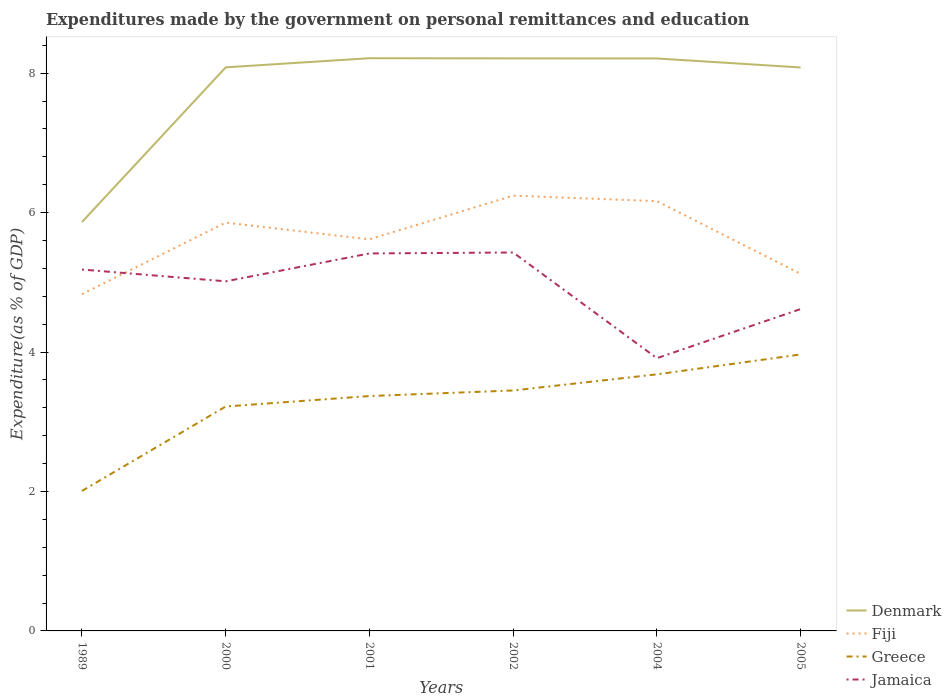Is the number of lines equal to the number of legend labels?
Your answer should be compact. Yes. Across all years, what is the maximum expenditures made by the government on personal remittances and education in Jamaica?
Provide a short and direct response. 3.91. What is the total expenditures made by the government on personal remittances and education in Greece in the graph?
Ensure brevity in your answer.  -0.31. What is the difference between the highest and the second highest expenditures made by the government on personal remittances and education in Greece?
Your answer should be very brief. 1.96. What is the difference between the highest and the lowest expenditures made by the government on personal remittances and education in Denmark?
Provide a short and direct response. 5. How many years are there in the graph?
Provide a short and direct response. 6. What is the difference between two consecutive major ticks on the Y-axis?
Make the answer very short. 2. Does the graph contain any zero values?
Provide a short and direct response. No. Does the graph contain grids?
Offer a terse response. No. How many legend labels are there?
Your answer should be very brief. 4. What is the title of the graph?
Offer a terse response. Expenditures made by the government on personal remittances and education. Does "Zimbabwe" appear as one of the legend labels in the graph?
Your response must be concise. No. What is the label or title of the X-axis?
Make the answer very short. Years. What is the label or title of the Y-axis?
Your response must be concise. Expenditure(as % of GDP). What is the Expenditure(as % of GDP) of Denmark in 1989?
Make the answer very short. 5.87. What is the Expenditure(as % of GDP) of Fiji in 1989?
Provide a succinct answer. 4.83. What is the Expenditure(as % of GDP) of Greece in 1989?
Give a very brief answer. 2.01. What is the Expenditure(as % of GDP) in Jamaica in 1989?
Keep it short and to the point. 5.18. What is the Expenditure(as % of GDP) in Denmark in 2000?
Your answer should be very brief. 8.08. What is the Expenditure(as % of GDP) in Fiji in 2000?
Your response must be concise. 5.86. What is the Expenditure(as % of GDP) in Greece in 2000?
Keep it short and to the point. 3.22. What is the Expenditure(as % of GDP) of Jamaica in 2000?
Make the answer very short. 5.02. What is the Expenditure(as % of GDP) in Denmark in 2001?
Offer a very short reply. 8.22. What is the Expenditure(as % of GDP) in Fiji in 2001?
Your answer should be compact. 5.62. What is the Expenditure(as % of GDP) of Greece in 2001?
Ensure brevity in your answer.  3.37. What is the Expenditure(as % of GDP) of Jamaica in 2001?
Make the answer very short. 5.41. What is the Expenditure(as % of GDP) in Denmark in 2002?
Keep it short and to the point. 8.21. What is the Expenditure(as % of GDP) in Fiji in 2002?
Your answer should be compact. 6.24. What is the Expenditure(as % of GDP) of Greece in 2002?
Provide a succinct answer. 3.45. What is the Expenditure(as % of GDP) of Jamaica in 2002?
Offer a very short reply. 5.43. What is the Expenditure(as % of GDP) of Denmark in 2004?
Offer a terse response. 8.21. What is the Expenditure(as % of GDP) in Fiji in 2004?
Provide a short and direct response. 6.16. What is the Expenditure(as % of GDP) of Greece in 2004?
Keep it short and to the point. 3.68. What is the Expenditure(as % of GDP) of Jamaica in 2004?
Ensure brevity in your answer.  3.91. What is the Expenditure(as % of GDP) in Denmark in 2005?
Your response must be concise. 8.08. What is the Expenditure(as % of GDP) of Fiji in 2005?
Offer a very short reply. 5.12. What is the Expenditure(as % of GDP) in Greece in 2005?
Offer a very short reply. 3.97. What is the Expenditure(as % of GDP) in Jamaica in 2005?
Ensure brevity in your answer.  4.62. Across all years, what is the maximum Expenditure(as % of GDP) in Denmark?
Give a very brief answer. 8.22. Across all years, what is the maximum Expenditure(as % of GDP) of Fiji?
Offer a terse response. 6.24. Across all years, what is the maximum Expenditure(as % of GDP) of Greece?
Ensure brevity in your answer.  3.97. Across all years, what is the maximum Expenditure(as % of GDP) of Jamaica?
Provide a short and direct response. 5.43. Across all years, what is the minimum Expenditure(as % of GDP) of Denmark?
Provide a short and direct response. 5.87. Across all years, what is the minimum Expenditure(as % of GDP) of Fiji?
Give a very brief answer. 4.83. Across all years, what is the minimum Expenditure(as % of GDP) in Greece?
Make the answer very short. 2.01. Across all years, what is the minimum Expenditure(as % of GDP) of Jamaica?
Ensure brevity in your answer.  3.91. What is the total Expenditure(as % of GDP) in Denmark in the graph?
Make the answer very short. 46.67. What is the total Expenditure(as % of GDP) in Fiji in the graph?
Provide a succinct answer. 33.84. What is the total Expenditure(as % of GDP) of Greece in the graph?
Provide a short and direct response. 19.69. What is the total Expenditure(as % of GDP) of Jamaica in the graph?
Make the answer very short. 29.57. What is the difference between the Expenditure(as % of GDP) in Denmark in 1989 and that in 2000?
Provide a succinct answer. -2.22. What is the difference between the Expenditure(as % of GDP) of Fiji in 1989 and that in 2000?
Offer a very short reply. -1.03. What is the difference between the Expenditure(as % of GDP) in Greece in 1989 and that in 2000?
Your answer should be very brief. -1.21. What is the difference between the Expenditure(as % of GDP) of Jamaica in 1989 and that in 2000?
Provide a short and direct response. 0.17. What is the difference between the Expenditure(as % of GDP) of Denmark in 1989 and that in 2001?
Give a very brief answer. -2.35. What is the difference between the Expenditure(as % of GDP) in Fiji in 1989 and that in 2001?
Provide a succinct answer. -0.79. What is the difference between the Expenditure(as % of GDP) in Greece in 1989 and that in 2001?
Provide a succinct answer. -1.36. What is the difference between the Expenditure(as % of GDP) in Jamaica in 1989 and that in 2001?
Offer a very short reply. -0.23. What is the difference between the Expenditure(as % of GDP) in Denmark in 1989 and that in 2002?
Give a very brief answer. -2.35. What is the difference between the Expenditure(as % of GDP) of Fiji in 1989 and that in 2002?
Give a very brief answer. -1.41. What is the difference between the Expenditure(as % of GDP) in Greece in 1989 and that in 2002?
Your answer should be very brief. -1.44. What is the difference between the Expenditure(as % of GDP) in Jamaica in 1989 and that in 2002?
Provide a succinct answer. -0.24. What is the difference between the Expenditure(as % of GDP) in Denmark in 1989 and that in 2004?
Provide a short and direct response. -2.35. What is the difference between the Expenditure(as % of GDP) in Fiji in 1989 and that in 2004?
Keep it short and to the point. -1.33. What is the difference between the Expenditure(as % of GDP) of Greece in 1989 and that in 2004?
Provide a short and direct response. -1.67. What is the difference between the Expenditure(as % of GDP) of Jamaica in 1989 and that in 2004?
Provide a succinct answer. 1.27. What is the difference between the Expenditure(as % of GDP) of Denmark in 1989 and that in 2005?
Provide a short and direct response. -2.22. What is the difference between the Expenditure(as % of GDP) in Fiji in 1989 and that in 2005?
Offer a terse response. -0.29. What is the difference between the Expenditure(as % of GDP) of Greece in 1989 and that in 2005?
Your response must be concise. -1.96. What is the difference between the Expenditure(as % of GDP) of Jamaica in 1989 and that in 2005?
Ensure brevity in your answer.  0.57. What is the difference between the Expenditure(as % of GDP) of Denmark in 2000 and that in 2001?
Your answer should be very brief. -0.13. What is the difference between the Expenditure(as % of GDP) in Fiji in 2000 and that in 2001?
Provide a short and direct response. 0.24. What is the difference between the Expenditure(as % of GDP) of Jamaica in 2000 and that in 2001?
Your response must be concise. -0.4. What is the difference between the Expenditure(as % of GDP) of Denmark in 2000 and that in 2002?
Your answer should be compact. -0.13. What is the difference between the Expenditure(as % of GDP) in Fiji in 2000 and that in 2002?
Offer a very short reply. -0.39. What is the difference between the Expenditure(as % of GDP) in Greece in 2000 and that in 2002?
Keep it short and to the point. -0.23. What is the difference between the Expenditure(as % of GDP) in Jamaica in 2000 and that in 2002?
Offer a very short reply. -0.41. What is the difference between the Expenditure(as % of GDP) of Denmark in 2000 and that in 2004?
Your response must be concise. -0.13. What is the difference between the Expenditure(as % of GDP) in Fiji in 2000 and that in 2004?
Your response must be concise. -0.31. What is the difference between the Expenditure(as % of GDP) in Greece in 2000 and that in 2004?
Your answer should be compact. -0.46. What is the difference between the Expenditure(as % of GDP) of Jamaica in 2000 and that in 2004?
Keep it short and to the point. 1.1. What is the difference between the Expenditure(as % of GDP) of Denmark in 2000 and that in 2005?
Give a very brief answer. 0. What is the difference between the Expenditure(as % of GDP) of Fiji in 2000 and that in 2005?
Ensure brevity in your answer.  0.74. What is the difference between the Expenditure(as % of GDP) in Greece in 2000 and that in 2005?
Give a very brief answer. -0.75. What is the difference between the Expenditure(as % of GDP) in Jamaica in 2000 and that in 2005?
Provide a succinct answer. 0.4. What is the difference between the Expenditure(as % of GDP) of Denmark in 2001 and that in 2002?
Your answer should be compact. 0. What is the difference between the Expenditure(as % of GDP) of Fiji in 2001 and that in 2002?
Your response must be concise. -0.63. What is the difference between the Expenditure(as % of GDP) in Greece in 2001 and that in 2002?
Offer a very short reply. -0.08. What is the difference between the Expenditure(as % of GDP) in Jamaica in 2001 and that in 2002?
Ensure brevity in your answer.  -0.01. What is the difference between the Expenditure(as % of GDP) of Denmark in 2001 and that in 2004?
Your answer should be very brief. 0. What is the difference between the Expenditure(as % of GDP) in Fiji in 2001 and that in 2004?
Your response must be concise. -0.55. What is the difference between the Expenditure(as % of GDP) in Greece in 2001 and that in 2004?
Your answer should be compact. -0.31. What is the difference between the Expenditure(as % of GDP) of Jamaica in 2001 and that in 2004?
Provide a succinct answer. 1.5. What is the difference between the Expenditure(as % of GDP) in Denmark in 2001 and that in 2005?
Keep it short and to the point. 0.13. What is the difference between the Expenditure(as % of GDP) in Fiji in 2001 and that in 2005?
Your response must be concise. 0.5. What is the difference between the Expenditure(as % of GDP) of Greece in 2001 and that in 2005?
Offer a terse response. -0.6. What is the difference between the Expenditure(as % of GDP) of Jamaica in 2001 and that in 2005?
Offer a terse response. 0.8. What is the difference between the Expenditure(as % of GDP) in Denmark in 2002 and that in 2004?
Offer a very short reply. 0. What is the difference between the Expenditure(as % of GDP) in Fiji in 2002 and that in 2004?
Your answer should be very brief. 0.08. What is the difference between the Expenditure(as % of GDP) in Greece in 2002 and that in 2004?
Give a very brief answer. -0.23. What is the difference between the Expenditure(as % of GDP) in Jamaica in 2002 and that in 2004?
Your answer should be compact. 1.52. What is the difference between the Expenditure(as % of GDP) of Denmark in 2002 and that in 2005?
Provide a succinct answer. 0.13. What is the difference between the Expenditure(as % of GDP) in Fiji in 2002 and that in 2005?
Offer a terse response. 1.12. What is the difference between the Expenditure(as % of GDP) of Greece in 2002 and that in 2005?
Give a very brief answer. -0.52. What is the difference between the Expenditure(as % of GDP) in Jamaica in 2002 and that in 2005?
Ensure brevity in your answer.  0.81. What is the difference between the Expenditure(as % of GDP) in Denmark in 2004 and that in 2005?
Provide a succinct answer. 0.13. What is the difference between the Expenditure(as % of GDP) of Fiji in 2004 and that in 2005?
Provide a short and direct response. 1.04. What is the difference between the Expenditure(as % of GDP) of Greece in 2004 and that in 2005?
Make the answer very short. -0.29. What is the difference between the Expenditure(as % of GDP) of Jamaica in 2004 and that in 2005?
Ensure brevity in your answer.  -0.7. What is the difference between the Expenditure(as % of GDP) in Denmark in 1989 and the Expenditure(as % of GDP) in Fiji in 2000?
Your answer should be very brief. 0.01. What is the difference between the Expenditure(as % of GDP) of Denmark in 1989 and the Expenditure(as % of GDP) of Greece in 2000?
Offer a terse response. 2.65. What is the difference between the Expenditure(as % of GDP) of Denmark in 1989 and the Expenditure(as % of GDP) of Jamaica in 2000?
Your response must be concise. 0.85. What is the difference between the Expenditure(as % of GDP) in Fiji in 1989 and the Expenditure(as % of GDP) in Greece in 2000?
Offer a terse response. 1.61. What is the difference between the Expenditure(as % of GDP) in Fiji in 1989 and the Expenditure(as % of GDP) in Jamaica in 2000?
Your response must be concise. -0.18. What is the difference between the Expenditure(as % of GDP) of Greece in 1989 and the Expenditure(as % of GDP) of Jamaica in 2000?
Keep it short and to the point. -3.01. What is the difference between the Expenditure(as % of GDP) of Denmark in 1989 and the Expenditure(as % of GDP) of Fiji in 2001?
Keep it short and to the point. 0.25. What is the difference between the Expenditure(as % of GDP) of Denmark in 1989 and the Expenditure(as % of GDP) of Greece in 2001?
Provide a short and direct response. 2.5. What is the difference between the Expenditure(as % of GDP) in Denmark in 1989 and the Expenditure(as % of GDP) in Jamaica in 2001?
Provide a succinct answer. 0.45. What is the difference between the Expenditure(as % of GDP) of Fiji in 1989 and the Expenditure(as % of GDP) of Greece in 2001?
Provide a short and direct response. 1.46. What is the difference between the Expenditure(as % of GDP) of Fiji in 1989 and the Expenditure(as % of GDP) of Jamaica in 2001?
Make the answer very short. -0.58. What is the difference between the Expenditure(as % of GDP) of Greece in 1989 and the Expenditure(as % of GDP) of Jamaica in 2001?
Give a very brief answer. -3.41. What is the difference between the Expenditure(as % of GDP) of Denmark in 1989 and the Expenditure(as % of GDP) of Fiji in 2002?
Provide a short and direct response. -0.38. What is the difference between the Expenditure(as % of GDP) of Denmark in 1989 and the Expenditure(as % of GDP) of Greece in 2002?
Your response must be concise. 2.42. What is the difference between the Expenditure(as % of GDP) in Denmark in 1989 and the Expenditure(as % of GDP) in Jamaica in 2002?
Ensure brevity in your answer.  0.44. What is the difference between the Expenditure(as % of GDP) of Fiji in 1989 and the Expenditure(as % of GDP) of Greece in 2002?
Provide a succinct answer. 1.38. What is the difference between the Expenditure(as % of GDP) of Fiji in 1989 and the Expenditure(as % of GDP) of Jamaica in 2002?
Offer a terse response. -0.6. What is the difference between the Expenditure(as % of GDP) of Greece in 1989 and the Expenditure(as % of GDP) of Jamaica in 2002?
Ensure brevity in your answer.  -3.42. What is the difference between the Expenditure(as % of GDP) in Denmark in 1989 and the Expenditure(as % of GDP) in Fiji in 2004?
Provide a succinct answer. -0.3. What is the difference between the Expenditure(as % of GDP) in Denmark in 1989 and the Expenditure(as % of GDP) in Greece in 2004?
Your answer should be compact. 2.18. What is the difference between the Expenditure(as % of GDP) in Denmark in 1989 and the Expenditure(as % of GDP) in Jamaica in 2004?
Keep it short and to the point. 1.95. What is the difference between the Expenditure(as % of GDP) of Fiji in 1989 and the Expenditure(as % of GDP) of Greece in 2004?
Ensure brevity in your answer.  1.15. What is the difference between the Expenditure(as % of GDP) of Fiji in 1989 and the Expenditure(as % of GDP) of Jamaica in 2004?
Keep it short and to the point. 0.92. What is the difference between the Expenditure(as % of GDP) of Greece in 1989 and the Expenditure(as % of GDP) of Jamaica in 2004?
Make the answer very short. -1.9. What is the difference between the Expenditure(as % of GDP) of Denmark in 1989 and the Expenditure(as % of GDP) of Fiji in 2005?
Provide a short and direct response. 0.74. What is the difference between the Expenditure(as % of GDP) in Denmark in 1989 and the Expenditure(as % of GDP) in Greece in 2005?
Make the answer very short. 1.9. What is the difference between the Expenditure(as % of GDP) in Denmark in 1989 and the Expenditure(as % of GDP) in Jamaica in 2005?
Offer a terse response. 1.25. What is the difference between the Expenditure(as % of GDP) in Fiji in 1989 and the Expenditure(as % of GDP) in Greece in 2005?
Your answer should be very brief. 0.87. What is the difference between the Expenditure(as % of GDP) in Fiji in 1989 and the Expenditure(as % of GDP) in Jamaica in 2005?
Your response must be concise. 0.21. What is the difference between the Expenditure(as % of GDP) in Greece in 1989 and the Expenditure(as % of GDP) in Jamaica in 2005?
Give a very brief answer. -2.61. What is the difference between the Expenditure(as % of GDP) in Denmark in 2000 and the Expenditure(as % of GDP) in Fiji in 2001?
Your answer should be compact. 2.47. What is the difference between the Expenditure(as % of GDP) in Denmark in 2000 and the Expenditure(as % of GDP) in Greece in 2001?
Offer a very short reply. 4.72. What is the difference between the Expenditure(as % of GDP) in Denmark in 2000 and the Expenditure(as % of GDP) in Jamaica in 2001?
Your response must be concise. 2.67. What is the difference between the Expenditure(as % of GDP) of Fiji in 2000 and the Expenditure(as % of GDP) of Greece in 2001?
Your answer should be compact. 2.49. What is the difference between the Expenditure(as % of GDP) in Fiji in 2000 and the Expenditure(as % of GDP) in Jamaica in 2001?
Your answer should be very brief. 0.44. What is the difference between the Expenditure(as % of GDP) of Greece in 2000 and the Expenditure(as % of GDP) of Jamaica in 2001?
Your response must be concise. -2.2. What is the difference between the Expenditure(as % of GDP) in Denmark in 2000 and the Expenditure(as % of GDP) in Fiji in 2002?
Ensure brevity in your answer.  1.84. What is the difference between the Expenditure(as % of GDP) of Denmark in 2000 and the Expenditure(as % of GDP) of Greece in 2002?
Your answer should be compact. 4.63. What is the difference between the Expenditure(as % of GDP) of Denmark in 2000 and the Expenditure(as % of GDP) of Jamaica in 2002?
Offer a very short reply. 2.66. What is the difference between the Expenditure(as % of GDP) of Fiji in 2000 and the Expenditure(as % of GDP) of Greece in 2002?
Offer a terse response. 2.41. What is the difference between the Expenditure(as % of GDP) of Fiji in 2000 and the Expenditure(as % of GDP) of Jamaica in 2002?
Provide a short and direct response. 0.43. What is the difference between the Expenditure(as % of GDP) in Greece in 2000 and the Expenditure(as % of GDP) in Jamaica in 2002?
Give a very brief answer. -2.21. What is the difference between the Expenditure(as % of GDP) of Denmark in 2000 and the Expenditure(as % of GDP) of Fiji in 2004?
Make the answer very short. 1.92. What is the difference between the Expenditure(as % of GDP) of Denmark in 2000 and the Expenditure(as % of GDP) of Greece in 2004?
Offer a terse response. 4.4. What is the difference between the Expenditure(as % of GDP) of Denmark in 2000 and the Expenditure(as % of GDP) of Jamaica in 2004?
Your answer should be compact. 4.17. What is the difference between the Expenditure(as % of GDP) in Fiji in 2000 and the Expenditure(as % of GDP) in Greece in 2004?
Ensure brevity in your answer.  2.18. What is the difference between the Expenditure(as % of GDP) of Fiji in 2000 and the Expenditure(as % of GDP) of Jamaica in 2004?
Your answer should be very brief. 1.94. What is the difference between the Expenditure(as % of GDP) in Greece in 2000 and the Expenditure(as % of GDP) in Jamaica in 2004?
Offer a very short reply. -0.69. What is the difference between the Expenditure(as % of GDP) in Denmark in 2000 and the Expenditure(as % of GDP) in Fiji in 2005?
Your answer should be compact. 2.96. What is the difference between the Expenditure(as % of GDP) of Denmark in 2000 and the Expenditure(as % of GDP) of Greece in 2005?
Keep it short and to the point. 4.12. What is the difference between the Expenditure(as % of GDP) of Denmark in 2000 and the Expenditure(as % of GDP) of Jamaica in 2005?
Give a very brief answer. 3.47. What is the difference between the Expenditure(as % of GDP) of Fiji in 2000 and the Expenditure(as % of GDP) of Greece in 2005?
Offer a very short reply. 1.89. What is the difference between the Expenditure(as % of GDP) in Fiji in 2000 and the Expenditure(as % of GDP) in Jamaica in 2005?
Provide a short and direct response. 1.24. What is the difference between the Expenditure(as % of GDP) of Greece in 2000 and the Expenditure(as % of GDP) of Jamaica in 2005?
Ensure brevity in your answer.  -1.4. What is the difference between the Expenditure(as % of GDP) in Denmark in 2001 and the Expenditure(as % of GDP) in Fiji in 2002?
Keep it short and to the point. 1.97. What is the difference between the Expenditure(as % of GDP) of Denmark in 2001 and the Expenditure(as % of GDP) of Greece in 2002?
Provide a short and direct response. 4.77. What is the difference between the Expenditure(as % of GDP) in Denmark in 2001 and the Expenditure(as % of GDP) in Jamaica in 2002?
Ensure brevity in your answer.  2.79. What is the difference between the Expenditure(as % of GDP) in Fiji in 2001 and the Expenditure(as % of GDP) in Greece in 2002?
Make the answer very short. 2.17. What is the difference between the Expenditure(as % of GDP) of Fiji in 2001 and the Expenditure(as % of GDP) of Jamaica in 2002?
Keep it short and to the point. 0.19. What is the difference between the Expenditure(as % of GDP) of Greece in 2001 and the Expenditure(as % of GDP) of Jamaica in 2002?
Keep it short and to the point. -2.06. What is the difference between the Expenditure(as % of GDP) in Denmark in 2001 and the Expenditure(as % of GDP) in Fiji in 2004?
Ensure brevity in your answer.  2.05. What is the difference between the Expenditure(as % of GDP) of Denmark in 2001 and the Expenditure(as % of GDP) of Greece in 2004?
Your answer should be very brief. 4.53. What is the difference between the Expenditure(as % of GDP) in Denmark in 2001 and the Expenditure(as % of GDP) in Jamaica in 2004?
Provide a short and direct response. 4.3. What is the difference between the Expenditure(as % of GDP) of Fiji in 2001 and the Expenditure(as % of GDP) of Greece in 2004?
Provide a succinct answer. 1.94. What is the difference between the Expenditure(as % of GDP) of Fiji in 2001 and the Expenditure(as % of GDP) of Jamaica in 2004?
Your response must be concise. 1.7. What is the difference between the Expenditure(as % of GDP) of Greece in 2001 and the Expenditure(as % of GDP) of Jamaica in 2004?
Your response must be concise. -0.54. What is the difference between the Expenditure(as % of GDP) in Denmark in 2001 and the Expenditure(as % of GDP) in Fiji in 2005?
Your response must be concise. 3.09. What is the difference between the Expenditure(as % of GDP) in Denmark in 2001 and the Expenditure(as % of GDP) in Greece in 2005?
Give a very brief answer. 4.25. What is the difference between the Expenditure(as % of GDP) in Denmark in 2001 and the Expenditure(as % of GDP) in Jamaica in 2005?
Provide a short and direct response. 3.6. What is the difference between the Expenditure(as % of GDP) of Fiji in 2001 and the Expenditure(as % of GDP) of Greece in 2005?
Offer a very short reply. 1.65. What is the difference between the Expenditure(as % of GDP) in Greece in 2001 and the Expenditure(as % of GDP) in Jamaica in 2005?
Your answer should be very brief. -1.25. What is the difference between the Expenditure(as % of GDP) of Denmark in 2002 and the Expenditure(as % of GDP) of Fiji in 2004?
Ensure brevity in your answer.  2.05. What is the difference between the Expenditure(as % of GDP) in Denmark in 2002 and the Expenditure(as % of GDP) in Greece in 2004?
Ensure brevity in your answer.  4.53. What is the difference between the Expenditure(as % of GDP) of Denmark in 2002 and the Expenditure(as % of GDP) of Jamaica in 2004?
Give a very brief answer. 4.3. What is the difference between the Expenditure(as % of GDP) of Fiji in 2002 and the Expenditure(as % of GDP) of Greece in 2004?
Ensure brevity in your answer.  2.56. What is the difference between the Expenditure(as % of GDP) in Fiji in 2002 and the Expenditure(as % of GDP) in Jamaica in 2004?
Provide a short and direct response. 2.33. What is the difference between the Expenditure(as % of GDP) of Greece in 2002 and the Expenditure(as % of GDP) of Jamaica in 2004?
Make the answer very short. -0.46. What is the difference between the Expenditure(as % of GDP) of Denmark in 2002 and the Expenditure(as % of GDP) of Fiji in 2005?
Your answer should be very brief. 3.09. What is the difference between the Expenditure(as % of GDP) of Denmark in 2002 and the Expenditure(as % of GDP) of Greece in 2005?
Provide a succinct answer. 4.25. What is the difference between the Expenditure(as % of GDP) in Denmark in 2002 and the Expenditure(as % of GDP) in Jamaica in 2005?
Make the answer very short. 3.6. What is the difference between the Expenditure(as % of GDP) of Fiji in 2002 and the Expenditure(as % of GDP) of Greece in 2005?
Your answer should be very brief. 2.28. What is the difference between the Expenditure(as % of GDP) of Fiji in 2002 and the Expenditure(as % of GDP) of Jamaica in 2005?
Your answer should be compact. 1.63. What is the difference between the Expenditure(as % of GDP) in Greece in 2002 and the Expenditure(as % of GDP) in Jamaica in 2005?
Keep it short and to the point. -1.17. What is the difference between the Expenditure(as % of GDP) of Denmark in 2004 and the Expenditure(as % of GDP) of Fiji in 2005?
Keep it short and to the point. 3.09. What is the difference between the Expenditure(as % of GDP) in Denmark in 2004 and the Expenditure(as % of GDP) in Greece in 2005?
Make the answer very short. 4.25. What is the difference between the Expenditure(as % of GDP) in Denmark in 2004 and the Expenditure(as % of GDP) in Jamaica in 2005?
Offer a terse response. 3.59. What is the difference between the Expenditure(as % of GDP) in Fiji in 2004 and the Expenditure(as % of GDP) in Greece in 2005?
Provide a short and direct response. 2.2. What is the difference between the Expenditure(as % of GDP) of Fiji in 2004 and the Expenditure(as % of GDP) of Jamaica in 2005?
Ensure brevity in your answer.  1.55. What is the difference between the Expenditure(as % of GDP) in Greece in 2004 and the Expenditure(as % of GDP) in Jamaica in 2005?
Make the answer very short. -0.94. What is the average Expenditure(as % of GDP) of Denmark per year?
Provide a succinct answer. 7.78. What is the average Expenditure(as % of GDP) of Fiji per year?
Offer a terse response. 5.64. What is the average Expenditure(as % of GDP) of Greece per year?
Provide a short and direct response. 3.28. What is the average Expenditure(as % of GDP) in Jamaica per year?
Make the answer very short. 4.93. In the year 1989, what is the difference between the Expenditure(as % of GDP) of Denmark and Expenditure(as % of GDP) of Fiji?
Ensure brevity in your answer.  1.03. In the year 1989, what is the difference between the Expenditure(as % of GDP) of Denmark and Expenditure(as % of GDP) of Greece?
Offer a terse response. 3.86. In the year 1989, what is the difference between the Expenditure(as % of GDP) of Denmark and Expenditure(as % of GDP) of Jamaica?
Provide a short and direct response. 0.68. In the year 1989, what is the difference between the Expenditure(as % of GDP) in Fiji and Expenditure(as % of GDP) in Greece?
Offer a very short reply. 2.82. In the year 1989, what is the difference between the Expenditure(as % of GDP) of Fiji and Expenditure(as % of GDP) of Jamaica?
Offer a terse response. -0.35. In the year 1989, what is the difference between the Expenditure(as % of GDP) of Greece and Expenditure(as % of GDP) of Jamaica?
Ensure brevity in your answer.  -3.18. In the year 2000, what is the difference between the Expenditure(as % of GDP) in Denmark and Expenditure(as % of GDP) in Fiji?
Offer a terse response. 2.23. In the year 2000, what is the difference between the Expenditure(as % of GDP) of Denmark and Expenditure(as % of GDP) of Greece?
Your answer should be compact. 4.87. In the year 2000, what is the difference between the Expenditure(as % of GDP) of Denmark and Expenditure(as % of GDP) of Jamaica?
Make the answer very short. 3.07. In the year 2000, what is the difference between the Expenditure(as % of GDP) of Fiji and Expenditure(as % of GDP) of Greece?
Provide a short and direct response. 2.64. In the year 2000, what is the difference between the Expenditure(as % of GDP) in Fiji and Expenditure(as % of GDP) in Jamaica?
Ensure brevity in your answer.  0.84. In the year 2000, what is the difference between the Expenditure(as % of GDP) in Greece and Expenditure(as % of GDP) in Jamaica?
Your response must be concise. -1.8. In the year 2001, what is the difference between the Expenditure(as % of GDP) of Denmark and Expenditure(as % of GDP) of Fiji?
Provide a short and direct response. 2.6. In the year 2001, what is the difference between the Expenditure(as % of GDP) of Denmark and Expenditure(as % of GDP) of Greece?
Give a very brief answer. 4.85. In the year 2001, what is the difference between the Expenditure(as % of GDP) in Denmark and Expenditure(as % of GDP) in Jamaica?
Provide a short and direct response. 2.8. In the year 2001, what is the difference between the Expenditure(as % of GDP) in Fiji and Expenditure(as % of GDP) in Greece?
Your response must be concise. 2.25. In the year 2001, what is the difference between the Expenditure(as % of GDP) of Fiji and Expenditure(as % of GDP) of Jamaica?
Your answer should be very brief. 0.2. In the year 2001, what is the difference between the Expenditure(as % of GDP) of Greece and Expenditure(as % of GDP) of Jamaica?
Your answer should be compact. -2.05. In the year 2002, what is the difference between the Expenditure(as % of GDP) of Denmark and Expenditure(as % of GDP) of Fiji?
Ensure brevity in your answer.  1.97. In the year 2002, what is the difference between the Expenditure(as % of GDP) of Denmark and Expenditure(as % of GDP) of Greece?
Your response must be concise. 4.76. In the year 2002, what is the difference between the Expenditure(as % of GDP) of Denmark and Expenditure(as % of GDP) of Jamaica?
Give a very brief answer. 2.78. In the year 2002, what is the difference between the Expenditure(as % of GDP) of Fiji and Expenditure(as % of GDP) of Greece?
Provide a succinct answer. 2.79. In the year 2002, what is the difference between the Expenditure(as % of GDP) of Fiji and Expenditure(as % of GDP) of Jamaica?
Your answer should be very brief. 0.82. In the year 2002, what is the difference between the Expenditure(as % of GDP) of Greece and Expenditure(as % of GDP) of Jamaica?
Offer a very short reply. -1.98. In the year 2004, what is the difference between the Expenditure(as % of GDP) in Denmark and Expenditure(as % of GDP) in Fiji?
Offer a terse response. 2.05. In the year 2004, what is the difference between the Expenditure(as % of GDP) in Denmark and Expenditure(as % of GDP) in Greece?
Offer a terse response. 4.53. In the year 2004, what is the difference between the Expenditure(as % of GDP) in Denmark and Expenditure(as % of GDP) in Jamaica?
Offer a terse response. 4.3. In the year 2004, what is the difference between the Expenditure(as % of GDP) of Fiji and Expenditure(as % of GDP) of Greece?
Keep it short and to the point. 2.48. In the year 2004, what is the difference between the Expenditure(as % of GDP) of Fiji and Expenditure(as % of GDP) of Jamaica?
Provide a succinct answer. 2.25. In the year 2004, what is the difference between the Expenditure(as % of GDP) in Greece and Expenditure(as % of GDP) in Jamaica?
Offer a terse response. -0.23. In the year 2005, what is the difference between the Expenditure(as % of GDP) of Denmark and Expenditure(as % of GDP) of Fiji?
Give a very brief answer. 2.96. In the year 2005, what is the difference between the Expenditure(as % of GDP) of Denmark and Expenditure(as % of GDP) of Greece?
Provide a short and direct response. 4.12. In the year 2005, what is the difference between the Expenditure(as % of GDP) of Denmark and Expenditure(as % of GDP) of Jamaica?
Your answer should be compact. 3.47. In the year 2005, what is the difference between the Expenditure(as % of GDP) of Fiji and Expenditure(as % of GDP) of Greece?
Your response must be concise. 1.16. In the year 2005, what is the difference between the Expenditure(as % of GDP) of Fiji and Expenditure(as % of GDP) of Jamaica?
Offer a terse response. 0.5. In the year 2005, what is the difference between the Expenditure(as % of GDP) in Greece and Expenditure(as % of GDP) in Jamaica?
Your answer should be very brief. -0.65. What is the ratio of the Expenditure(as % of GDP) in Denmark in 1989 to that in 2000?
Your answer should be compact. 0.73. What is the ratio of the Expenditure(as % of GDP) of Fiji in 1989 to that in 2000?
Your response must be concise. 0.82. What is the ratio of the Expenditure(as % of GDP) of Greece in 1989 to that in 2000?
Make the answer very short. 0.62. What is the ratio of the Expenditure(as % of GDP) of Jamaica in 1989 to that in 2000?
Offer a very short reply. 1.03. What is the ratio of the Expenditure(as % of GDP) in Denmark in 1989 to that in 2001?
Your answer should be very brief. 0.71. What is the ratio of the Expenditure(as % of GDP) in Fiji in 1989 to that in 2001?
Provide a short and direct response. 0.86. What is the ratio of the Expenditure(as % of GDP) of Greece in 1989 to that in 2001?
Offer a very short reply. 0.6. What is the ratio of the Expenditure(as % of GDP) of Jamaica in 1989 to that in 2001?
Ensure brevity in your answer.  0.96. What is the ratio of the Expenditure(as % of GDP) in Denmark in 1989 to that in 2002?
Your answer should be very brief. 0.71. What is the ratio of the Expenditure(as % of GDP) in Fiji in 1989 to that in 2002?
Your response must be concise. 0.77. What is the ratio of the Expenditure(as % of GDP) in Greece in 1989 to that in 2002?
Offer a terse response. 0.58. What is the ratio of the Expenditure(as % of GDP) in Jamaica in 1989 to that in 2002?
Make the answer very short. 0.95. What is the ratio of the Expenditure(as % of GDP) of Fiji in 1989 to that in 2004?
Offer a very short reply. 0.78. What is the ratio of the Expenditure(as % of GDP) in Greece in 1989 to that in 2004?
Keep it short and to the point. 0.55. What is the ratio of the Expenditure(as % of GDP) in Jamaica in 1989 to that in 2004?
Your answer should be very brief. 1.32. What is the ratio of the Expenditure(as % of GDP) in Denmark in 1989 to that in 2005?
Provide a succinct answer. 0.73. What is the ratio of the Expenditure(as % of GDP) in Fiji in 1989 to that in 2005?
Make the answer very short. 0.94. What is the ratio of the Expenditure(as % of GDP) in Greece in 1989 to that in 2005?
Ensure brevity in your answer.  0.51. What is the ratio of the Expenditure(as % of GDP) in Jamaica in 1989 to that in 2005?
Ensure brevity in your answer.  1.12. What is the ratio of the Expenditure(as % of GDP) of Denmark in 2000 to that in 2001?
Offer a very short reply. 0.98. What is the ratio of the Expenditure(as % of GDP) in Fiji in 2000 to that in 2001?
Offer a very short reply. 1.04. What is the ratio of the Expenditure(as % of GDP) of Greece in 2000 to that in 2001?
Provide a succinct answer. 0.96. What is the ratio of the Expenditure(as % of GDP) in Jamaica in 2000 to that in 2001?
Make the answer very short. 0.93. What is the ratio of the Expenditure(as % of GDP) of Denmark in 2000 to that in 2002?
Ensure brevity in your answer.  0.98. What is the ratio of the Expenditure(as % of GDP) in Fiji in 2000 to that in 2002?
Keep it short and to the point. 0.94. What is the ratio of the Expenditure(as % of GDP) of Greece in 2000 to that in 2002?
Make the answer very short. 0.93. What is the ratio of the Expenditure(as % of GDP) in Jamaica in 2000 to that in 2002?
Keep it short and to the point. 0.92. What is the ratio of the Expenditure(as % of GDP) of Denmark in 2000 to that in 2004?
Ensure brevity in your answer.  0.98. What is the ratio of the Expenditure(as % of GDP) of Fiji in 2000 to that in 2004?
Your answer should be compact. 0.95. What is the ratio of the Expenditure(as % of GDP) of Greece in 2000 to that in 2004?
Offer a terse response. 0.87. What is the ratio of the Expenditure(as % of GDP) of Jamaica in 2000 to that in 2004?
Offer a terse response. 1.28. What is the ratio of the Expenditure(as % of GDP) of Fiji in 2000 to that in 2005?
Your response must be concise. 1.14. What is the ratio of the Expenditure(as % of GDP) in Greece in 2000 to that in 2005?
Ensure brevity in your answer.  0.81. What is the ratio of the Expenditure(as % of GDP) in Jamaica in 2000 to that in 2005?
Your answer should be compact. 1.09. What is the ratio of the Expenditure(as % of GDP) of Denmark in 2001 to that in 2002?
Offer a terse response. 1. What is the ratio of the Expenditure(as % of GDP) in Fiji in 2001 to that in 2002?
Keep it short and to the point. 0.9. What is the ratio of the Expenditure(as % of GDP) in Greece in 2001 to that in 2002?
Provide a short and direct response. 0.98. What is the ratio of the Expenditure(as % of GDP) in Jamaica in 2001 to that in 2002?
Give a very brief answer. 1. What is the ratio of the Expenditure(as % of GDP) in Fiji in 2001 to that in 2004?
Your answer should be very brief. 0.91. What is the ratio of the Expenditure(as % of GDP) of Greece in 2001 to that in 2004?
Provide a succinct answer. 0.92. What is the ratio of the Expenditure(as % of GDP) in Jamaica in 2001 to that in 2004?
Keep it short and to the point. 1.38. What is the ratio of the Expenditure(as % of GDP) of Denmark in 2001 to that in 2005?
Keep it short and to the point. 1.02. What is the ratio of the Expenditure(as % of GDP) in Fiji in 2001 to that in 2005?
Offer a terse response. 1.1. What is the ratio of the Expenditure(as % of GDP) in Greece in 2001 to that in 2005?
Your response must be concise. 0.85. What is the ratio of the Expenditure(as % of GDP) of Jamaica in 2001 to that in 2005?
Offer a very short reply. 1.17. What is the ratio of the Expenditure(as % of GDP) of Fiji in 2002 to that in 2004?
Keep it short and to the point. 1.01. What is the ratio of the Expenditure(as % of GDP) of Greece in 2002 to that in 2004?
Offer a terse response. 0.94. What is the ratio of the Expenditure(as % of GDP) in Jamaica in 2002 to that in 2004?
Give a very brief answer. 1.39. What is the ratio of the Expenditure(as % of GDP) in Denmark in 2002 to that in 2005?
Your response must be concise. 1.02. What is the ratio of the Expenditure(as % of GDP) in Fiji in 2002 to that in 2005?
Provide a succinct answer. 1.22. What is the ratio of the Expenditure(as % of GDP) of Greece in 2002 to that in 2005?
Offer a terse response. 0.87. What is the ratio of the Expenditure(as % of GDP) of Jamaica in 2002 to that in 2005?
Ensure brevity in your answer.  1.18. What is the ratio of the Expenditure(as % of GDP) of Fiji in 2004 to that in 2005?
Your answer should be compact. 1.2. What is the ratio of the Expenditure(as % of GDP) in Greece in 2004 to that in 2005?
Give a very brief answer. 0.93. What is the ratio of the Expenditure(as % of GDP) in Jamaica in 2004 to that in 2005?
Your answer should be very brief. 0.85. What is the difference between the highest and the second highest Expenditure(as % of GDP) in Denmark?
Give a very brief answer. 0. What is the difference between the highest and the second highest Expenditure(as % of GDP) of Fiji?
Keep it short and to the point. 0.08. What is the difference between the highest and the second highest Expenditure(as % of GDP) of Greece?
Make the answer very short. 0.29. What is the difference between the highest and the second highest Expenditure(as % of GDP) of Jamaica?
Keep it short and to the point. 0.01. What is the difference between the highest and the lowest Expenditure(as % of GDP) in Denmark?
Provide a short and direct response. 2.35. What is the difference between the highest and the lowest Expenditure(as % of GDP) in Fiji?
Your answer should be compact. 1.41. What is the difference between the highest and the lowest Expenditure(as % of GDP) of Greece?
Your answer should be compact. 1.96. What is the difference between the highest and the lowest Expenditure(as % of GDP) of Jamaica?
Your answer should be very brief. 1.52. 